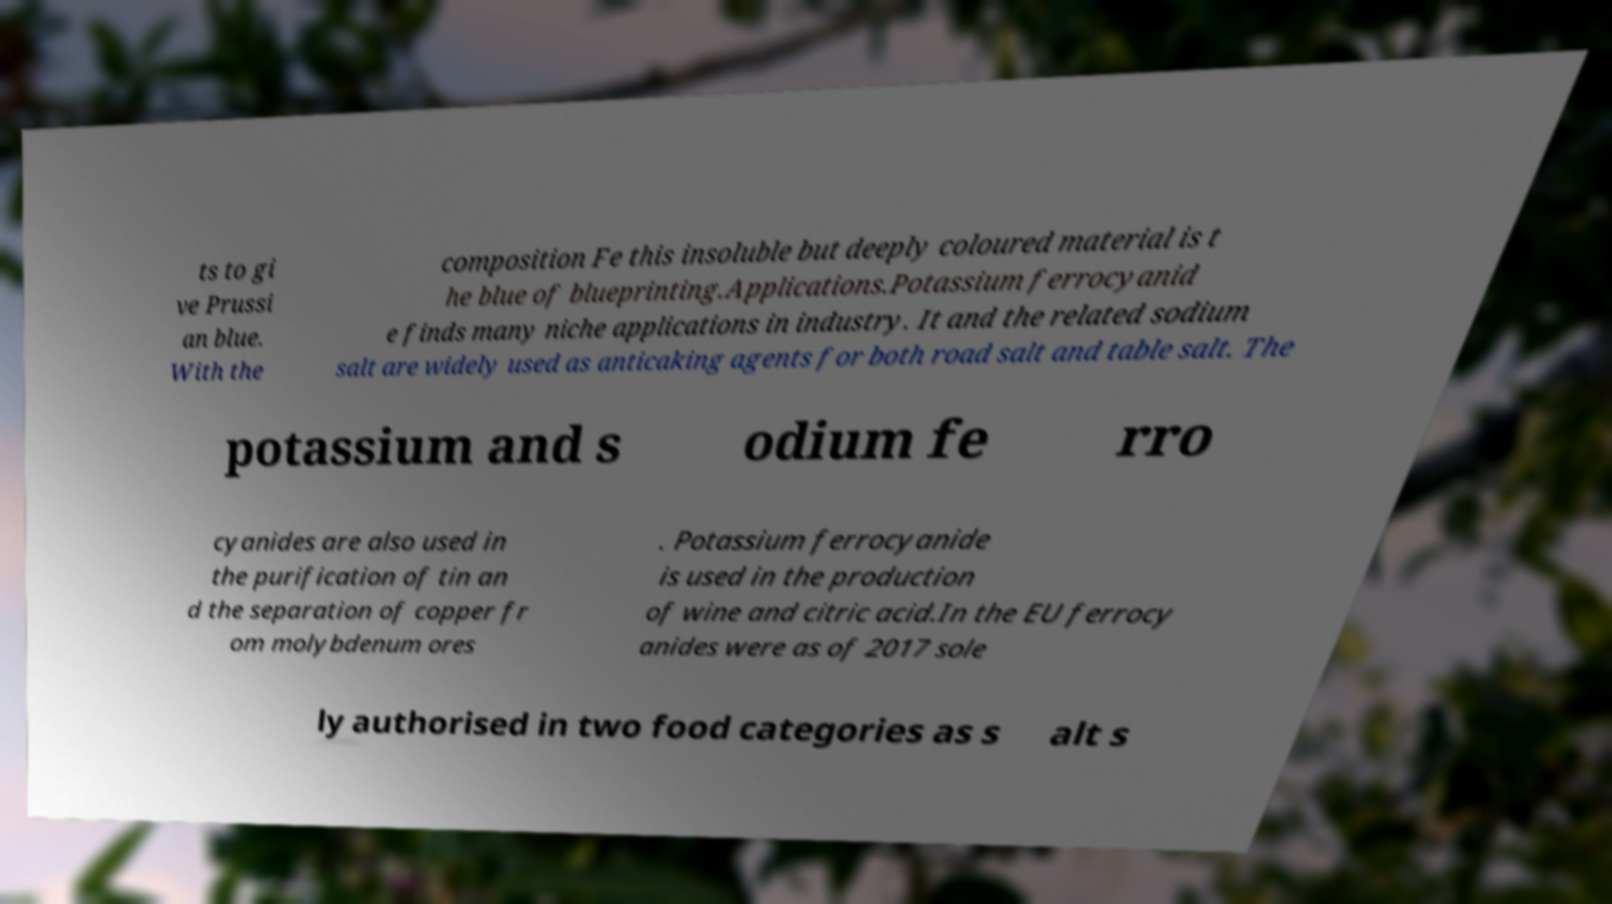For documentation purposes, I need the text within this image transcribed. Could you provide that? ts to gi ve Prussi an blue. With the composition Fe this insoluble but deeply coloured material is t he blue of blueprinting.Applications.Potassium ferrocyanid e finds many niche applications in industry. It and the related sodium salt are widely used as anticaking agents for both road salt and table salt. The potassium and s odium fe rro cyanides are also used in the purification of tin an d the separation of copper fr om molybdenum ores . Potassium ferrocyanide is used in the production of wine and citric acid.In the EU ferrocy anides were as of 2017 sole ly authorised in two food categories as s alt s 